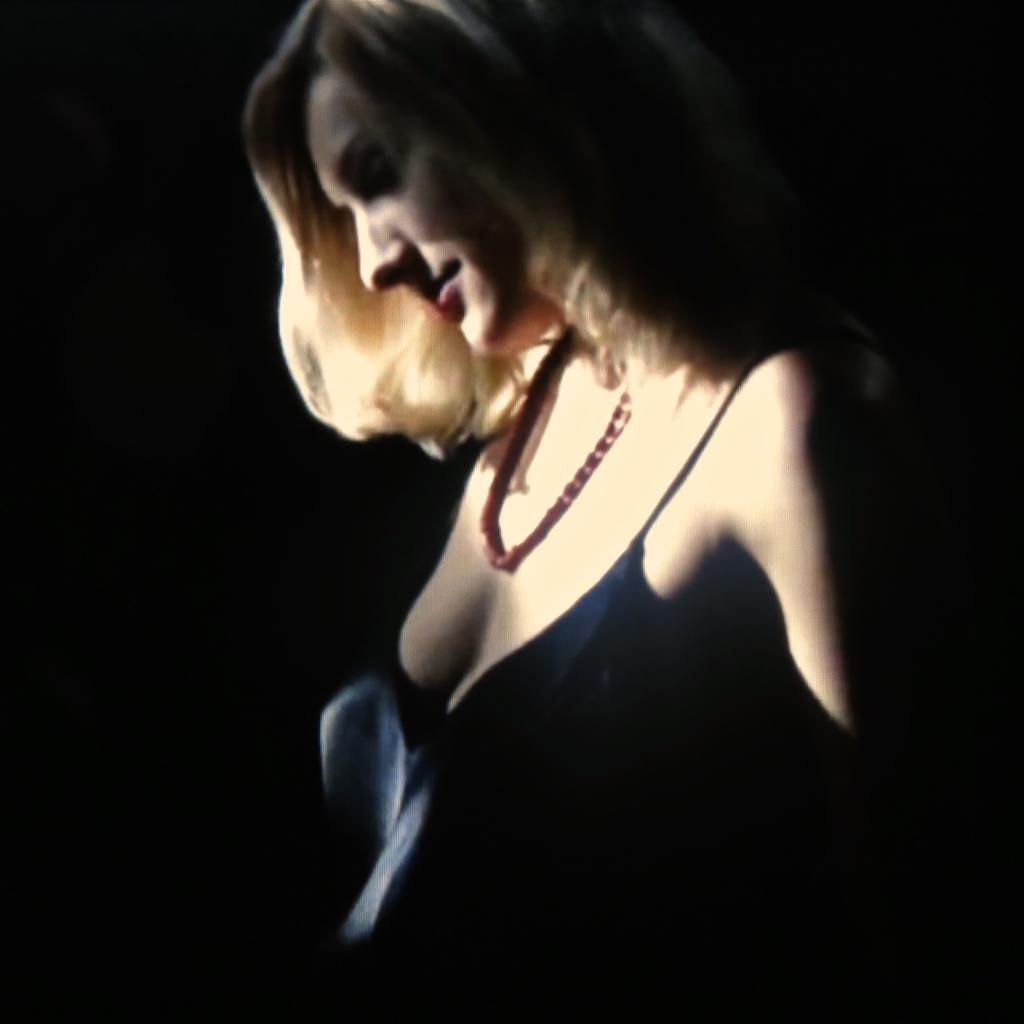What is the main subject of the picture? The main subject of the picture is a woman. What is the woman wearing in the picture? The woman is wearing a dress and a necklace in the picture. How many goldfish can be seen swimming in the woman's dress in the image? There are no goldfish present in the image, and they are not swimming in the woman's dress. 